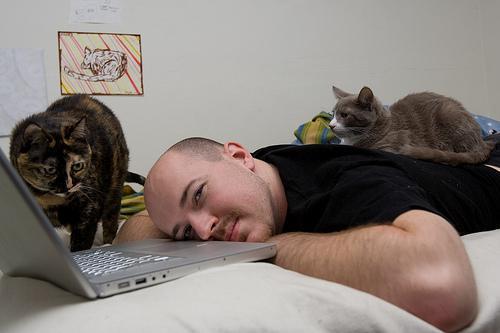How many cats do you see?
Give a very brief answer. 2. How many laptops?
Give a very brief answer. 1. How many cats are in the scene?
Give a very brief answer. 2. How many cats are standing?
Give a very brief answer. 1. 